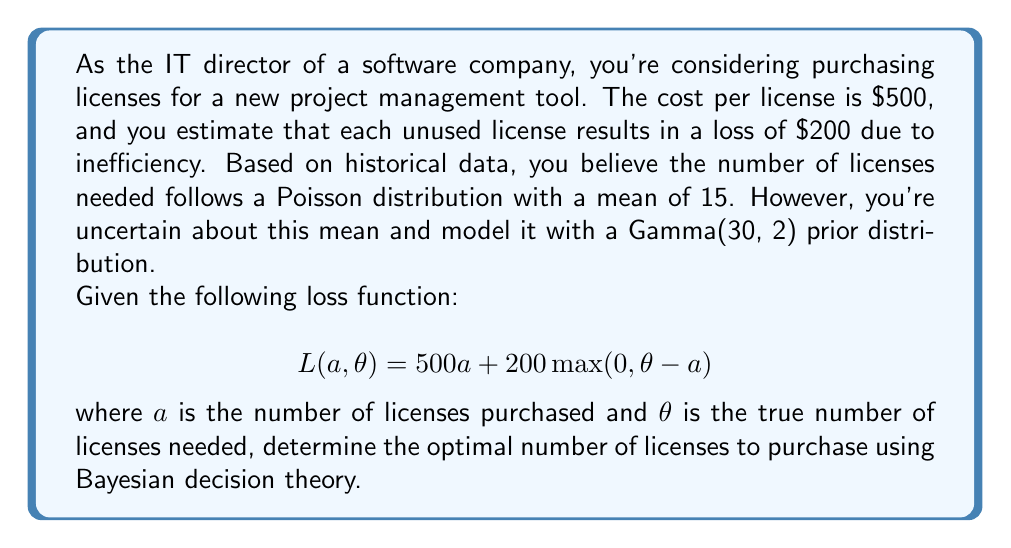Can you answer this question? To solve this problem, we'll follow these steps:

1. Define the posterior distribution
2. Set up the expected loss function
3. Minimize the expected loss

Step 1: Define the posterior distribution

The prior distribution for $\theta$ is Gamma(30, 2), and the likelihood is Poisson($\theta$). The posterior distribution is also a Gamma distribution:

$$\theta | x \sim \text{Gamma}(30 + x, 2 + 1) = \text{Gamma}(30 + 15, 3) = \text{Gamma}(45, 3)$$

Step 2: Set up the expected loss function

The expected loss is:

$$\begin{align*}
E[L(a)] &= 500a + 200E[\max(0, \theta - a)] \\
&= 500a + 200\int_a^\infty (\theta - a)f(\theta|x)d\theta
\end{align*}$$

Where $f(\theta|x)$ is the posterior density of $\theta$.

Step 3: Minimize the expected loss

To minimize the expected loss, we differentiate with respect to $a$ and set it to zero:

$$\frac{d}{da}E[L(a)] = 500 - 200\int_a^\infty f(\theta|x)d\theta = 0$$

This simplifies to:

$$\int_a^\infty f(\theta|x)d\theta = \frac{5}{2}$$

For the Gamma(45, 3) distribution, this integral is the complementary cumulative distribution function (CCDF). We need to find $a$ such that:

$$\text{CCDF}_{\text{Gamma}(45, 3)}(a) = \frac{5}{2}$$

Using numerical methods or statistical software, we can solve this equation to find:

$$a \approx 16.33$$

Since we can only purchase whole licenses, we round to the nearest integer:

$$a^* = 16$$

This is the optimal number of licenses to purchase according to Bayesian decision theory.
Answer: 16 licenses 